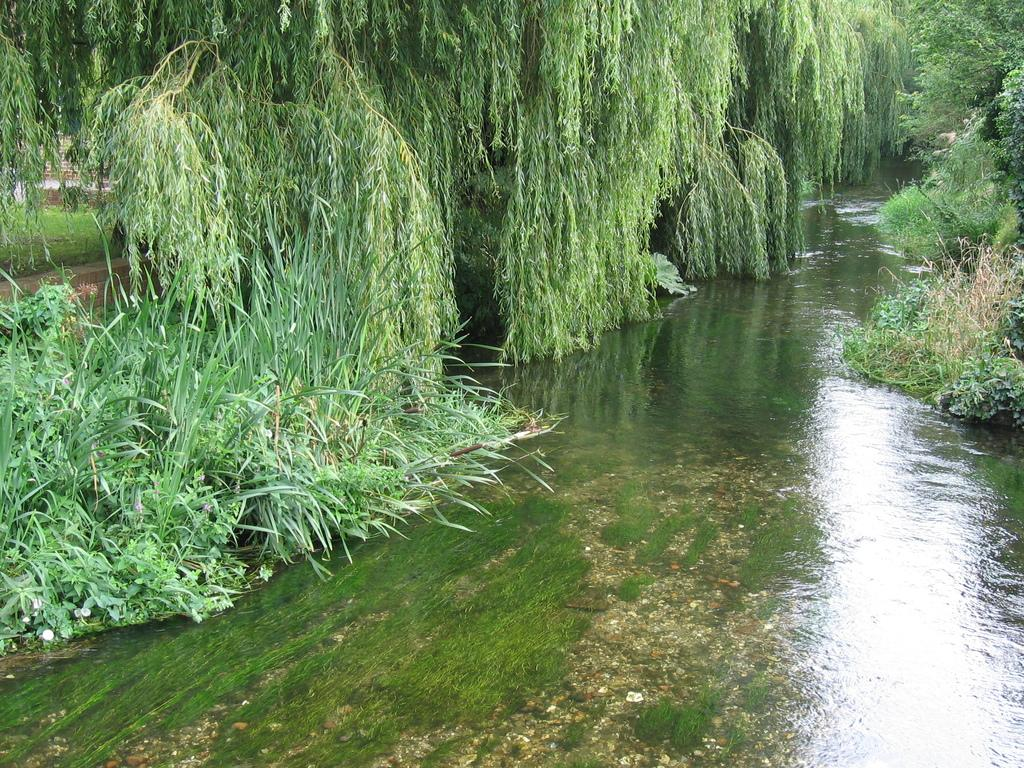What type of vegetation can be seen in the image? There are trees in the image. What natural element is visible in the image? There is water visible in the image. What type of material is present in the image? There are stones in the image. What can be seen in the background of the image? The background of the image includes grass. What type of cake is being served in the image? There is no cake present in the image; it features trees, water, stones, and grass. What type of society is depicted in the image? The image does not depict a society; it focuses on natural elements and materials. 